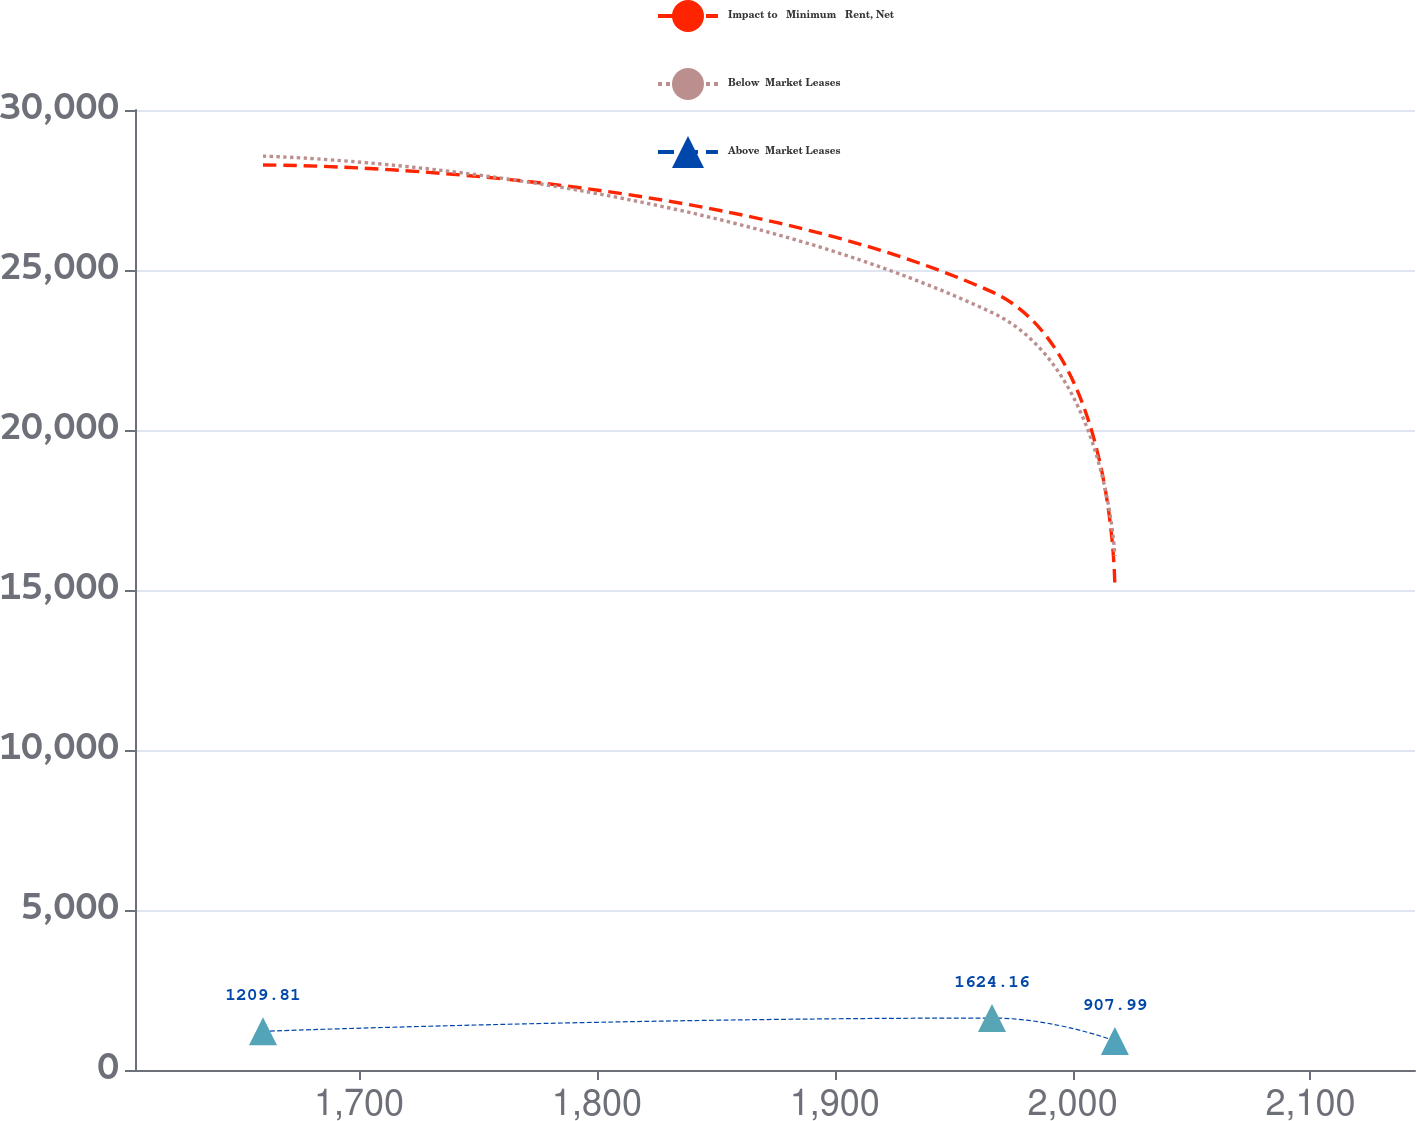Convert chart to OTSL. <chart><loc_0><loc_0><loc_500><loc_500><line_chart><ecel><fcel>Impact to   Minimum   Rent, Net<fcel>Below  Market Leases<fcel>Above  Market Leases<nl><fcel>1659.62<fcel>28283.1<fcel>28558.2<fcel>1209.81<nl><fcel>1966.11<fcel>24316.2<fcel>23670.5<fcel>1624.16<nl><fcel>2017.76<fcel>15050.3<fcel>16064.7<fcel>907.99<nl><fcel>2146.11<fcel>9720.31<fcel>12146.9<fcel>2564.56<nl><fcel>2197.76<fcel>4676.4<fcel>6543.28<fcel>2385.05<nl></chart> 